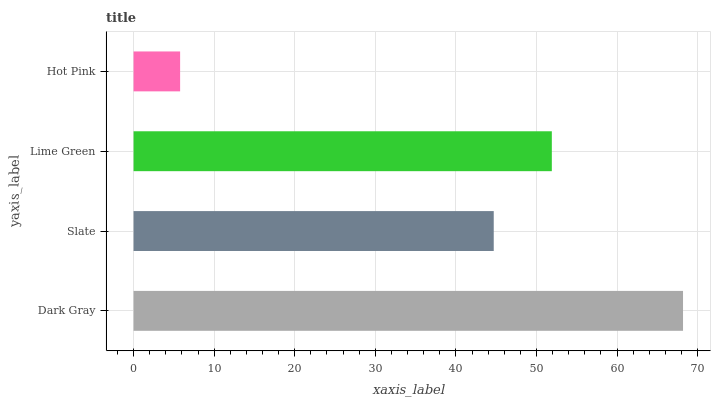Is Hot Pink the minimum?
Answer yes or no. Yes. Is Dark Gray the maximum?
Answer yes or no. Yes. Is Slate the minimum?
Answer yes or no. No. Is Slate the maximum?
Answer yes or no. No. Is Dark Gray greater than Slate?
Answer yes or no. Yes. Is Slate less than Dark Gray?
Answer yes or no. Yes. Is Slate greater than Dark Gray?
Answer yes or no. No. Is Dark Gray less than Slate?
Answer yes or no. No. Is Lime Green the high median?
Answer yes or no. Yes. Is Slate the low median?
Answer yes or no. Yes. Is Dark Gray the high median?
Answer yes or no. No. Is Dark Gray the low median?
Answer yes or no. No. 